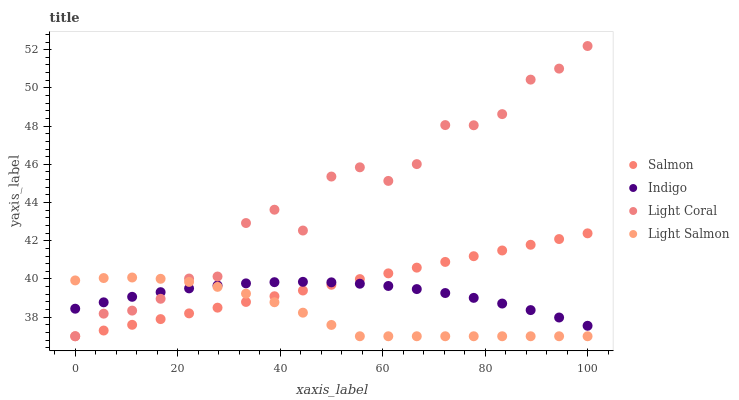Does Light Salmon have the minimum area under the curve?
Answer yes or no. Yes. Does Light Coral have the maximum area under the curve?
Answer yes or no. Yes. Does Indigo have the minimum area under the curve?
Answer yes or no. No. Does Indigo have the maximum area under the curve?
Answer yes or no. No. Is Salmon the smoothest?
Answer yes or no. Yes. Is Light Coral the roughest?
Answer yes or no. Yes. Is Indigo the smoothest?
Answer yes or no. No. Is Indigo the roughest?
Answer yes or no. No. Does Light Coral have the lowest value?
Answer yes or no. Yes. Does Indigo have the lowest value?
Answer yes or no. No. Does Light Coral have the highest value?
Answer yes or no. Yes. Does Light Salmon have the highest value?
Answer yes or no. No. Does Light Salmon intersect Light Coral?
Answer yes or no. Yes. Is Light Salmon less than Light Coral?
Answer yes or no. No. Is Light Salmon greater than Light Coral?
Answer yes or no. No. 